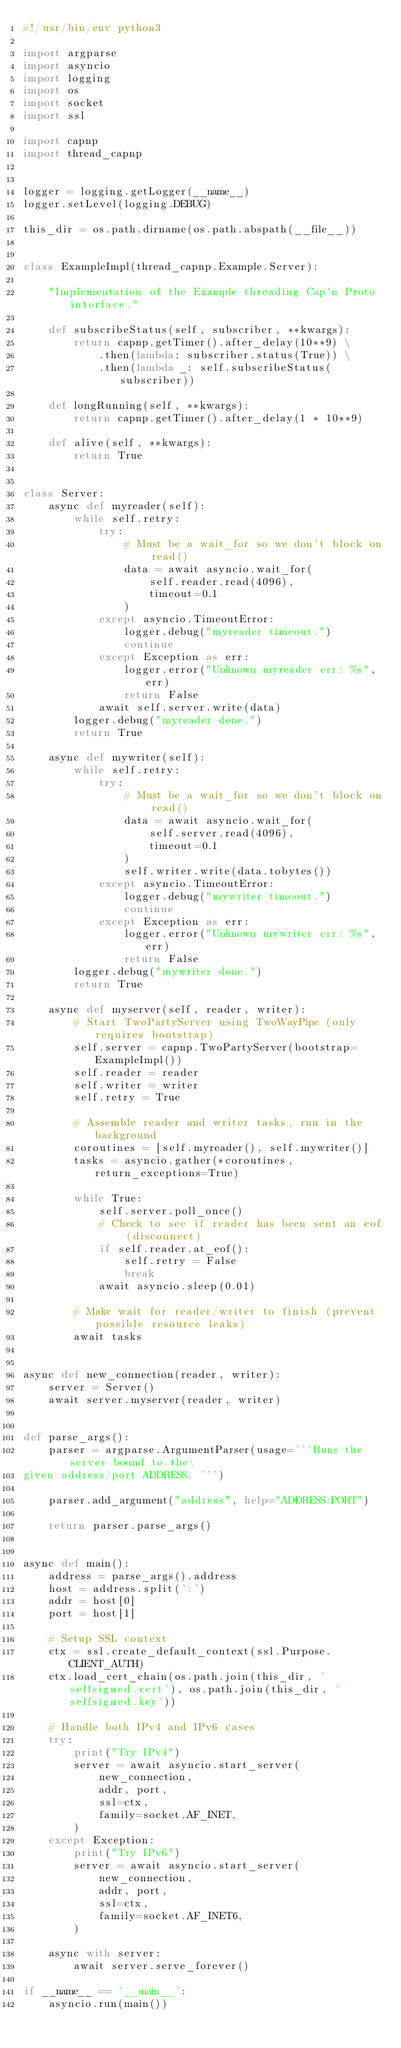<code> <loc_0><loc_0><loc_500><loc_500><_Python_>#!/usr/bin/env python3

import argparse
import asyncio
import logging
import os
import socket
import ssl

import capnp
import thread_capnp


logger = logging.getLogger(__name__)
logger.setLevel(logging.DEBUG)

this_dir = os.path.dirname(os.path.abspath(__file__))


class ExampleImpl(thread_capnp.Example.Server):

    "Implementation of the Example threading Cap'n Proto interface."

    def subscribeStatus(self, subscriber, **kwargs):
        return capnp.getTimer().after_delay(10**9) \
            .then(lambda: subscriber.status(True)) \
            .then(lambda _: self.subscribeStatus(subscriber))

    def longRunning(self, **kwargs):
        return capnp.getTimer().after_delay(1 * 10**9)

    def alive(self, **kwargs):
        return True


class Server:
    async def myreader(self):
        while self.retry:
            try:
                # Must be a wait_for so we don't block on read()
                data = await asyncio.wait_for(
                    self.reader.read(4096),
                    timeout=0.1
                )
            except asyncio.TimeoutError:
                logger.debug("myreader timeout.")
                continue
            except Exception as err:
                logger.error("Unknown myreader err: %s", err)
                return False
            await self.server.write(data)
        logger.debug("myreader done.")
        return True

    async def mywriter(self):
        while self.retry:
            try:
                # Must be a wait_for so we don't block on read()
                data = await asyncio.wait_for(
                    self.server.read(4096),
                    timeout=0.1
                )
                self.writer.write(data.tobytes())
            except asyncio.TimeoutError:
                logger.debug("mywriter timeout.")
                continue
            except Exception as err:
                logger.error("Unknown mywriter err: %s", err)
                return False
        logger.debug("mywriter done.")
        return True

    async def myserver(self, reader, writer):
        # Start TwoPartyServer using TwoWayPipe (only requires bootstrap)
        self.server = capnp.TwoPartyServer(bootstrap=ExampleImpl())
        self.reader = reader
        self.writer = writer
        self.retry = True

        # Assemble reader and writer tasks, run in the background
        coroutines = [self.myreader(), self.mywriter()]
        tasks = asyncio.gather(*coroutines, return_exceptions=True)

        while True:
            self.server.poll_once()
            # Check to see if reader has been sent an eof (disconnect)
            if self.reader.at_eof():
                self.retry = False
                break
            await asyncio.sleep(0.01)

        # Make wait for reader/writer to finish (prevent possible resource leaks)
        await tasks


async def new_connection(reader, writer):
    server = Server()
    await server.myserver(reader, writer)


def parse_args():
    parser = argparse.ArgumentParser(usage='''Runs the server bound to the\
given address/port ADDRESS. ''')

    parser.add_argument("address", help="ADDRESS:PORT")

    return parser.parse_args()


async def main():
    address = parse_args().address
    host = address.split(':')
    addr = host[0]
    port = host[1]

    # Setup SSL context
    ctx = ssl.create_default_context(ssl.Purpose.CLIENT_AUTH)
    ctx.load_cert_chain(os.path.join(this_dir, 'selfsigned.cert'), os.path.join(this_dir, 'selfsigned.key'))

    # Handle both IPv4 and IPv6 cases
    try:
        print("Try IPv4")
        server = await asyncio.start_server(
            new_connection,
            addr, port,
            ssl=ctx,
            family=socket.AF_INET,
        )
    except Exception:
        print("Try IPv6")
        server = await asyncio.start_server(
            new_connection,
            addr, port,
            ssl=ctx,
            family=socket.AF_INET6,
        )

    async with server:
        await server.serve_forever()

if __name__ == '__main__':
    asyncio.run(main())
</code> 